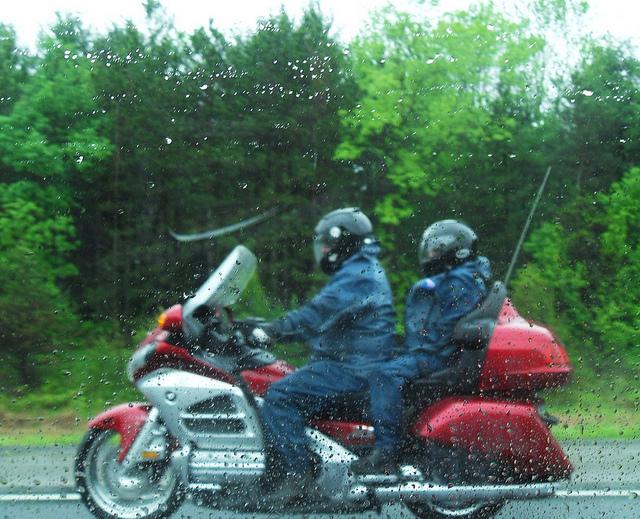Is it raining?
Give a very brief answer. Yes. Are they matching?
Give a very brief answer. Yes. What color is the motorcycle?
Be succinct. Red. 